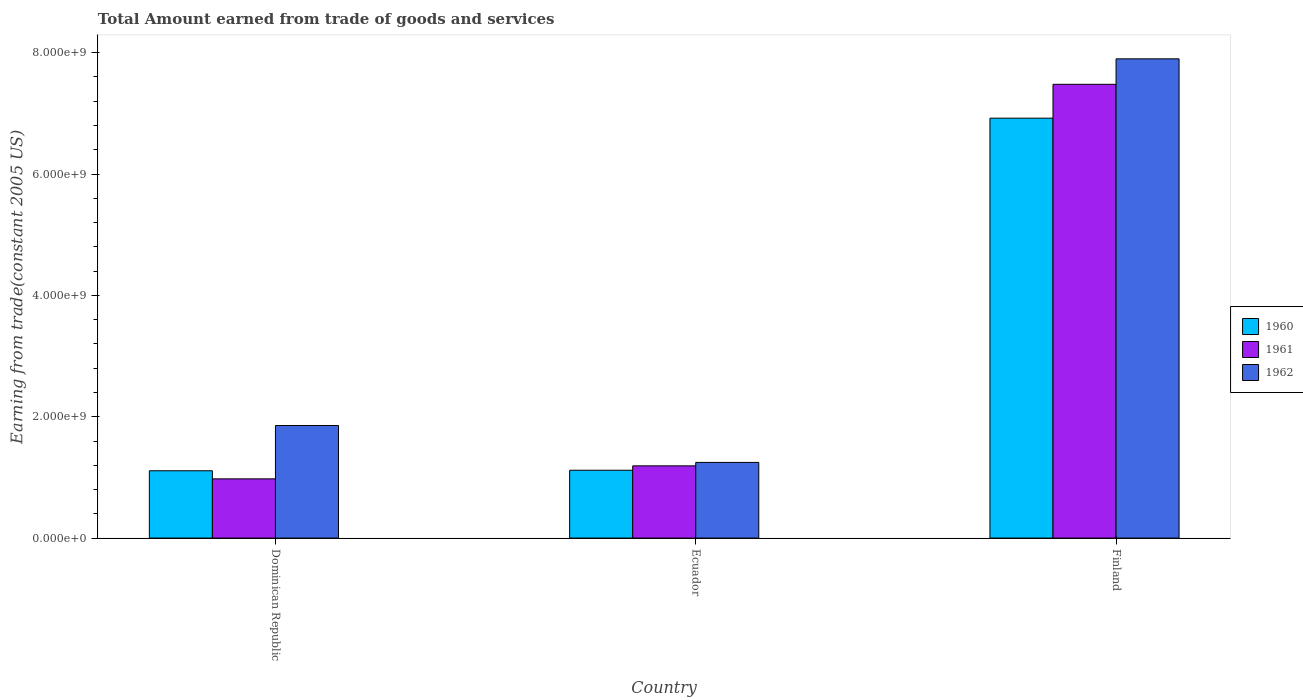How many groups of bars are there?
Provide a succinct answer. 3. What is the label of the 2nd group of bars from the left?
Provide a succinct answer. Ecuador. What is the total amount earned by trading goods and services in 1961 in Finland?
Offer a very short reply. 7.48e+09. Across all countries, what is the maximum total amount earned by trading goods and services in 1960?
Your answer should be very brief. 6.92e+09. Across all countries, what is the minimum total amount earned by trading goods and services in 1962?
Give a very brief answer. 1.25e+09. In which country was the total amount earned by trading goods and services in 1961 minimum?
Offer a terse response. Dominican Republic. What is the total total amount earned by trading goods and services in 1962 in the graph?
Your answer should be very brief. 1.10e+1. What is the difference between the total amount earned by trading goods and services in 1962 in Dominican Republic and that in Ecuador?
Your answer should be compact. 6.08e+08. What is the difference between the total amount earned by trading goods and services in 1960 in Dominican Republic and the total amount earned by trading goods and services in 1962 in Ecuador?
Make the answer very short. -1.37e+08. What is the average total amount earned by trading goods and services in 1962 per country?
Offer a terse response. 3.67e+09. What is the difference between the total amount earned by trading goods and services of/in 1961 and total amount earned by trading goods and services of/in 1962 in Ecuador?
Give a very brief answer. -5.67e+07. What is the ratio of the total amount earned by trading goods and services in 1962 in Ecuador to that in Finland?
Ensure brevity in your answer.  0.16. Is the difference between the total amount earned by trading goods and services in 1961 in Dominican Republic and Finland greater than the difference between the total amount earned by trading goods and services in 1962 in Dominican Republic and Finland?
Ensure brevity in your answer.  No. What is the difference between the highest and the second highest total amount earned by trading goods and services in 1962?
Offer a terse response. 6.08e+08. What is the difference between the highest and the lowest total amount earned by trading goods and services in 1960?
Your answer should be very brief. 5.81e+09. In how many countries, is the total amount earned by trading goods and services in 1961 greater than the average total amount earned by trading goods and services in 1961 taken over all countries?
Your answer should be compact. 1. Is the sum of the total amount earned by trading goods and services in 1962 in Dominican Republic and Ecuador greater than the maximum total amount earned by trading goods and services in 1961 across all countries?
Give a very brief answer. No. What does the 3rd bar from the left in Dominican Republic represents?
Provide a short and direct response. 1962. Is it the case that in every country, the sum of the total amount earned by trading goods and services in 1962 and total amount earned by trading goods and services in 1960 is greater than the total amount earned by trading goods and services in 1961?
Your response must be concise. Yes. How many bars are there?
Offer a very short reply. 9. Are the values on the major ticks of Y-axis written in scientific E-notation?
Your answer should be very brief. Yes. Does the graph contain grids?
Offer a terse response. No. How many legend labels are there?
Make the answer very short. 3. How are the legend labels stacked?
Provide a short and direct response. Vertical. What is the title of the graph?
Provide a short and direct response. Total Amount earned from trade of goods and services. Does "1961" appear as one of the legend labels in the graph?
Ensure brevity in your answer.  Yes. What is the label or title of the X-axis?
Offer a terse response. Country. What is the label or title of the Y-axis?
Provide a short and direct response. Earning from trade(constant 2005 US). What is the Earning from trade(constant 2005 US) in 1960 in Dominican Republic?
Give a very brief answer. 1.11e+09. What is the Earning from trade(constant 2005 US) in 1961 in Dominican Republic?
Make the answer very short. 9.76e+08. What is the Earning from trade(constant 2005 US) of 1962 in Dominican Republic?
Offer a terse response. 1.86e+09. What is the Earning from trade(constant 2005 US) in 1960 in Ecuador?
Offer a very short reply. 1.12e+09. What is the Earning from trade(constant 2005 US) in 1961 in Ecuador?
Ensure brevity in your answer.  1.19e+09. What is the Earning from trade(constant 2005 US) of 1962 in Ecuador?
Offer a terse response. 1.25e+09. What is the Earning from trade(constant 2005 US) in 1960 in Finland?
Make the answer very short. 6.92e+09. What is the Earning from trade(constant 2005 US) in 1961 in Finland?
Offer a very short reply. 7.48e+09. What is the Earning from trade(constant 2005 US) of 1962 in Finland?
Your answer should be compact. 7.90e+09. Across all countries, what is the maximum Earning from trade(constant 2005 US) in 1960?
Offer a very short reply. 6.92e+09. Across all countries, what is the maximum Earning from trade(constant 2005 US) of 1961?
Provide a short and direct response. 7.48e+09. Across all countries, what is the maximum Earning from trade(constant 2005 US) of 1962?
Provide a succinct answer. 7.90e+09. Across all countries, what is the minimum Earning from trade(constant 2005 US) of 1960?
Offer a terse response. 1.11e+09. Across all countries, what is the minimum Earning from trade(constant 2005 US) of 1961?
Offer a very short reply. 9.76e+08. Across all countries, what is the minimum Earning from trade(constant 2005 US) in 1962?
Offer a terse response. 1.25e+09. What is the total Earning from trade(constant 2005 US) of 1960 in the graph?
Your answer should be compact. 9.15e+09. What is the total Earning from trade(constant 2005 US) of 1961 in the graph?
Ensure brevity in your answer.  9.64e+09. What is the total Earning from trade(constant 2005 US) of 1962 in the graph?
Make the answer very short. 1.10e+1. What is the difference between the Earning from trade(constant 2005 US) of 1960 in Dominican Republic and that in Ecuador?
Your response must be concise. -8.29e+06. What is the difference between the Earning from trade(constant 2005 US) of 1961 in Dominican Republic and that in Ecuador?
Keep it short and to the point. -2.14e+08. What is the difference between the Earning from trade(constant 2005 US) of 1962 in Dominican Republic and that in Ecuador?
Provide a succinct answer. 6.08e+08. What is the difference between the Earning from trade(constant 2005 US) of 1960 in Dominican Republic and that in Finland?
Your answer should be compact. -5.81e+09. What is the difference between the Earning from trade(constant 2005 US) in 1961 in Dominican Republic and that in Finland?
Provide a succinct answer. -6.50e+09. What is the difference between the Earning from trade(constant 2005 US) of 1962 in Dominican Republic and that in Finland?
Offer a very short reply. -6.04e+09. What is the difference between the Earning from trade(constant 2005 US) in 1960 in Ecuador and that in Finland?
Keep it short and to the point. -5.80e+09. What is the difference between the Earning from trade(constant 2005 US) in 1961 in Ecuador and that in Finland?
Give a very brief answer. -6.29e+09. What is the difference between the Earning from trade(constant 2005 US) in 1962 in Ecuador and that in Finland?
Your answer should be compact. -6.65e+09. What is the difference between the Earning from trade(constant 2005 US) in 1960 in Dominican Republic and the Earning from trade(constant 2005 US) in 1961 in Ecuador?
Your answer should be compact. -8.07e+07. What is the difference between the Earning from trade(constant 2005 US) of 1960 in Dominican Republic and the Earning from trade(constant 2005 US) of 1962 in Ecuador?
Offer a terse response. -1.37e+08. What is the difference between the Earning from trade(constant 2005 US) in 1961 in Dominican Republic and the Earning from trade(constant 2005 US) in 1962 in Ecuador?
Your answer should be compact. -2.71e+08. What is the difference between the Earning from trade(constant 2005 US) of 1960 in Dominican Republic and the Earning from trade(constant 2005 US) of 1961 in Finland?
Make the answer very short. -6.37e+09. What is the difference between the Earning from trade(constant 2005 US) of 1960 in Dominican Republic and the Earning from trade(constant 2005 US) of 1962 in Finland?
Keep it short and to the point. -6.79e+09. What is the difference between the Earning from trade(constant 2005 US) in 1961 in Dominican Republic and the Earning from trade(constant 2005 US) in 1962 in Finland?
Make the answer very short. -6.92e+09. What is the difference between the Earning from trade(constant 2005 US) of 1960 in Ecuador and the Earning from trade(constant 2005 US) of 1961 in Finland?
Offer a very short reply. -6.36e+09. What is the difference between the Earning from trade(constant 2005 US) in 1960 in Ecuador and the Earning from trade(constant 2005 US) in 1962 in Finland?
Give a very brief answer. -6.78e+09. What is the difference between the Earning from trade(constant 2005 US) in 1961 in Ecuador and the Earning from trade(constant 2005 US) in 1962 in Finland?
Your answer should be very brief. -6.71e+09. What is the average Earning from trade(constant 2005 US) in 1960 per country?
Your answer should be compact. 3.05e+09. What is the average Earning from trade(constant 2005 US) in 1961 per country?
Your answer should be very brief. 3.21e+09. What is the average Earning from trade(constant 2005 US) of 1962 per country?
Your response must be concise. 3.67e+09. What is the difference between the Earning from trade(constant 2005 US) in 1960 and Earning from trade(constant 2005 US) in 1961 in Dominican Republic?
Keep it short and to the point. 1.34e+08. What is the difference between the Earning from trade(constant 2005 US) in 1960 and Earning from trade(constant 2005 US) in 1962 in Dominican Republic?
Your answer should be compact. -7.45e+08. What is the difference between the Earning from trade(constant 2005 US) in 1961 and Earning from trade(constant 2005 US) in 1962 in Dominican Republic?
Provide a succinct answer. -8.79e+08. What is the difference between the Earning from trade(constant 2005 US) in 1960 and Earning from trade(constant 2005 US) in 1961 in Ecuador?
Your answer should be very brief. -7.24e+07. What is the difference between the Earning from trade(constant 2005 US) of 1960 and Earning from trade(constant 2005 US) of 1962 in Ecuador?
Make the answer very short. -1.29e+08. What is the difference between the Earning from trade(constant 2005 US) of 1961 and Earning from trade(constant 2005 US) of 1962 in Ecuador?
Keep it short and to the point. -5.67e+07. What is the difference between the Earning from trade(constant 2005 US) of 1960 and Earning from trade(constant 2005 US) of 1961 in Finland?
Keep it short and to the point. -5.58e+08. What is the difference between the Earning from trade(constant 2005 US) in 1960 and Earning from trade(constant 2005 US) in 1962 in Finland?
Your answer should be very brief. -9.78e+08. What is the difference between the Earning from trade(constant 2005 US) of 1961 and Earning from trade(constant 2005 US) of 1962 in Finland?
Ensure brevity in your answer.  -4.20e+08. What is the ratio of the Earning from trade(constant 2005 US) in 1960 in Dominican Republic to that in Ecuador?
Your answer should be very brief. 0.99. What is the ratio of the Earning from trade(constant 2005 US) in 1961 in Dominican Republic to that in Ecuador?
Provide a succinct answer. 0.82. What is the ratio of the Earning from trade(constant 2005 US) of 1962 in Dominican Republic to that in Ecuador?
Provide a succinct answer. 1.49. What is the ratio of the Earning from trade(constant 2005 US) of 1960 in Dominican Republic to that in Finland?
Your response must be concise. 0.16. What is the ratio of the Earning from trade(constant 2005 US) in 1961 in Dominican Republic to that in Finland?
Give a very brief answer. 0.13. What is the ratio of the Earning from trade(constant 2005 US) of 1962 in Dominican Republic to that in Finland?
Make the answer very short. 0.23. What is the ratio of the Earning from trade(constant 2005 US) in 1960 in Ecuador to that in Finland?
Make the answer very short. 0.16. What is the ratio of the Earning from trade(constant 2005 US) of 1961 in Ecuador to that in Finland?
Provide a short and direct response. 0.16. What is the ratio of the Earning from trade(constant 2005 US) of 1962 in Ecuador to that in Finland?
Your answer should be very brief. 0.16. What is the difference between the highest and the second highest Earning from trade(constant 2005 US) in 1960?
Your response must be concise. 5.80e+09. What is the difference between the highest and the second highest Earning from trade(constant 2005 US) in 1961?
Provide a short and direct response. 6.29e+09. What is the difference between the highest and the second highest Earning from trade(constant 2005 US) of 1962?
Provide a short and direct response. 6.04e+09. What is the difference between the highest and the lowest Earning from trade(constant 2005 US) of 1960?
Provide a short and direct response. 5.81e+09. What is the difference between the highest and the lowest Earning from trade(constant 2005 US) in 1961?
Ensure brevity in your answer.  6.50e+09. What is the difference between the highest and the lowest Earning from trade(constant 2005 US) of 1962?
Your response must be concise. 6.65e+09. 